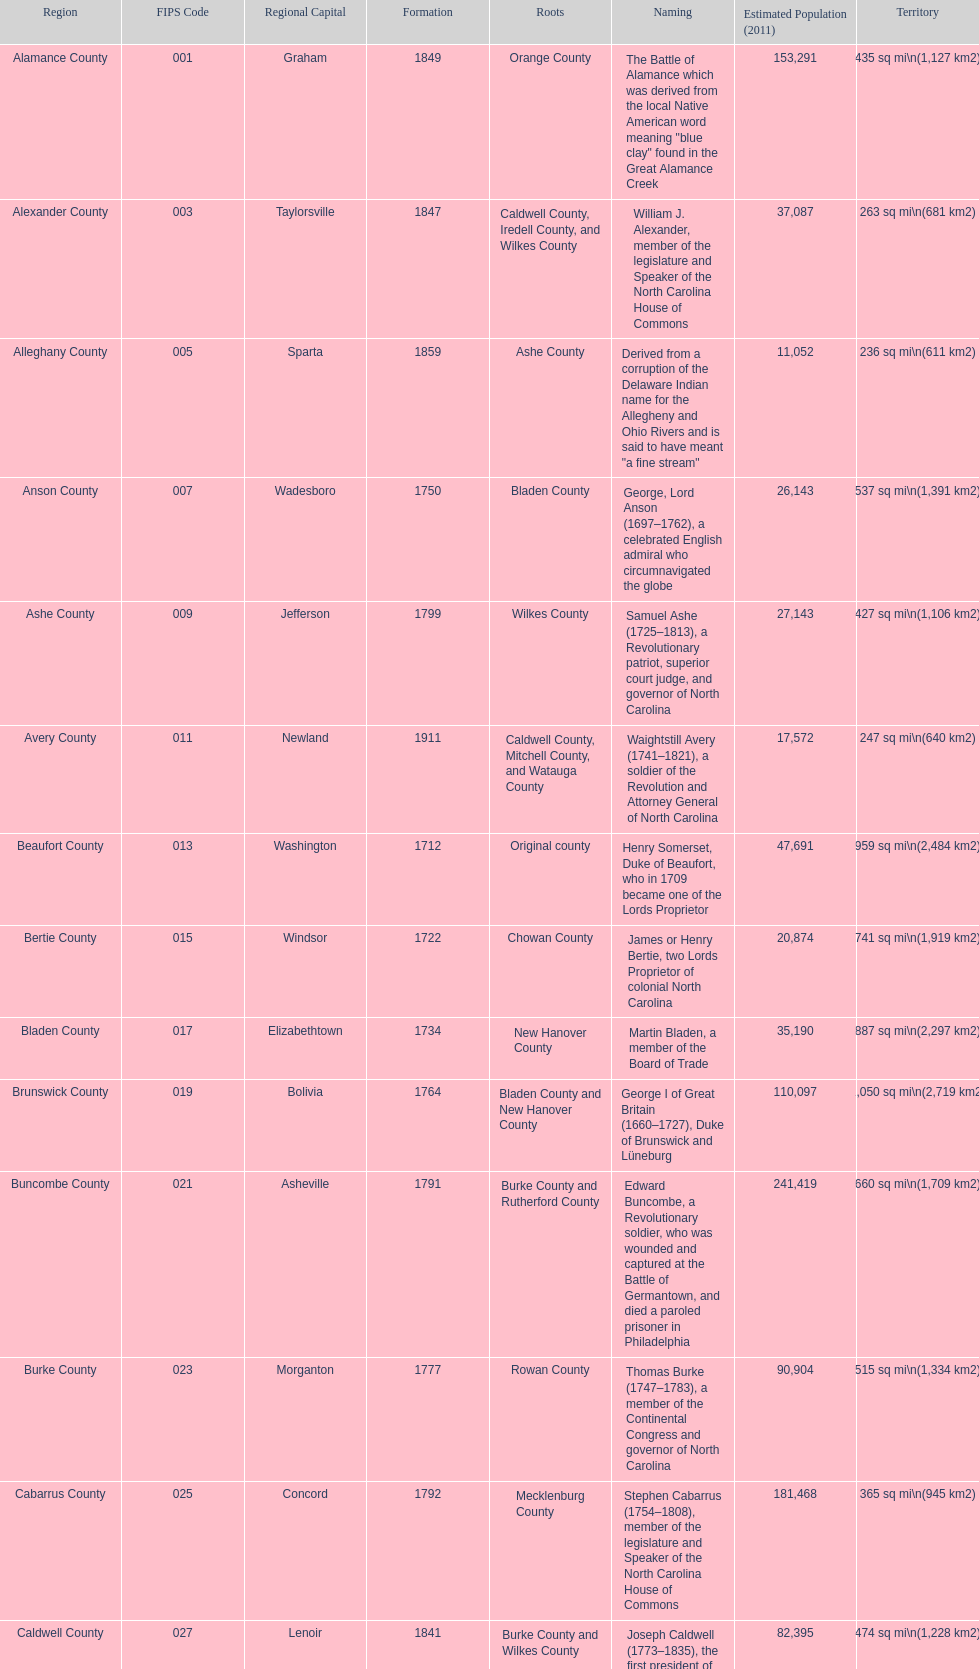What is the only county whose name comes from a battle? Alamance County. 